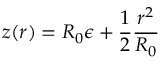Convert formula to latex. <formula><loc_0><loc_0><loc_500><loc_500>z ( r ) = R _ { 0 } { \epsilon } + \frac { 1 } { 2 } \frac { r ^ { 2 } } { R _ { 0 } }</formula> 